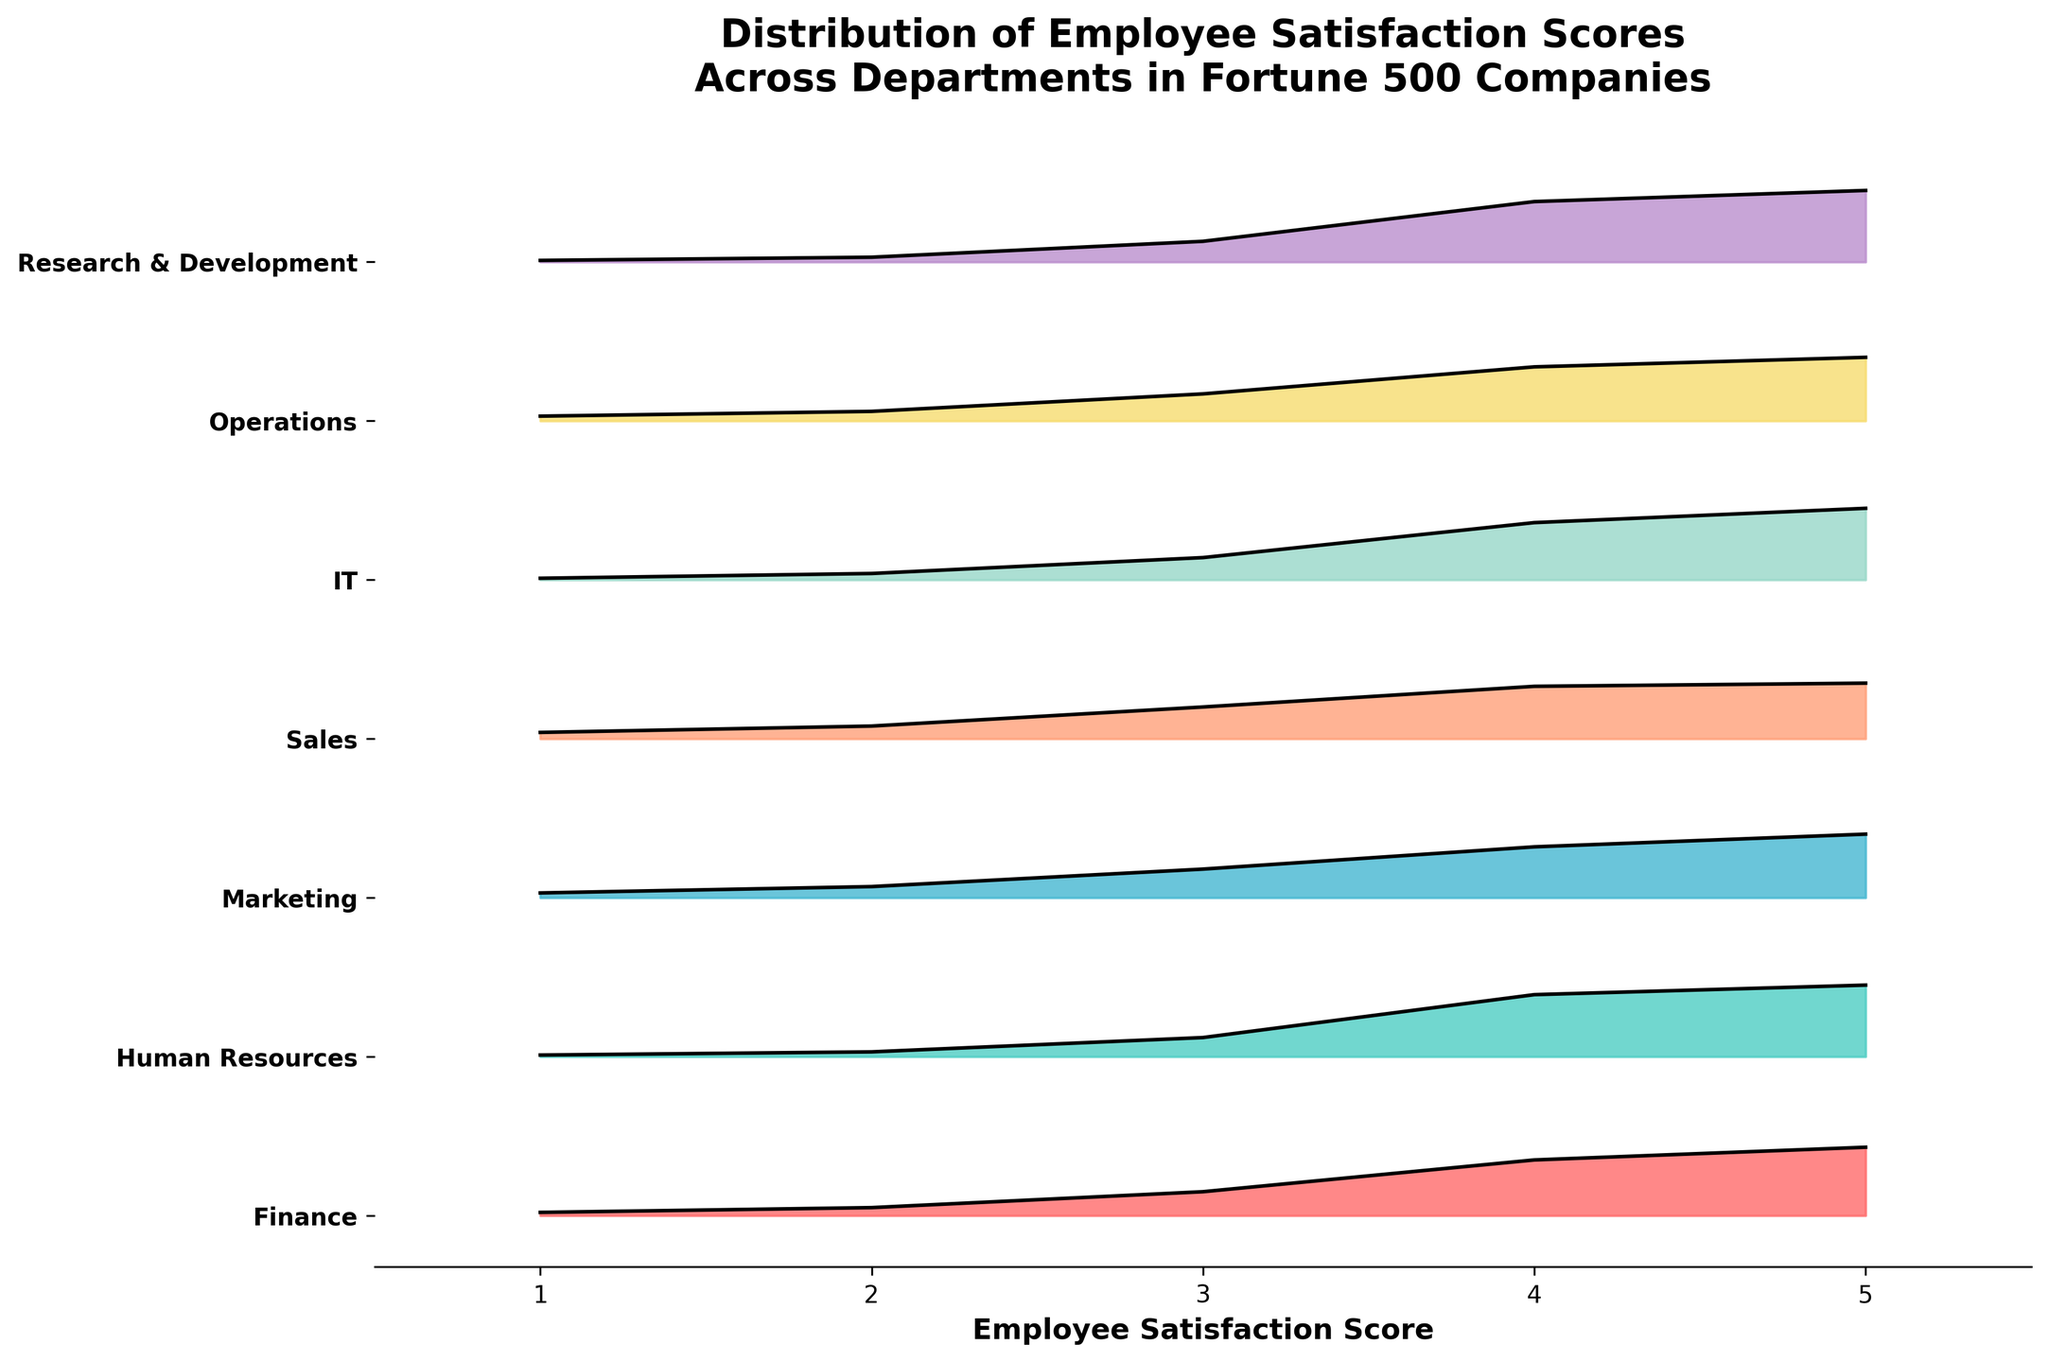What's the title of the plot? The title is displayed at the top of the plot, it provides information on the subject being visualized.
Answer: Distribution of Employee Satisfaction Scores Across Departments in Fortune 500 Companies What are the departments shown in the plot? The departments can be identified from the labels on the y-axis of the plot. They include Finance, Human Resources, Marketing, Sales, IT, Operations, and Research & Development.
Answer: Finance, Human Resources, Marketing, Sales, IT, Operations, Research & Development Which department has the highest density for employee satisfaction score 5? By comparing the density values for satisfaction score 5 across all departments in the plot, we see that Human Resources, IT, and Research & Development all have the highest density value of 0.45.
Answer: Human Resources, IT, Research & Development What's the general trend in employee satisfaction scores across departments? The general trend can be observed by noting the shape of the density curves across the departments. The density values often increase towards higher satisfaction scores, indicating higher satisfaction generally.
Answer: Higher satisfaction generally Which department shows the widest distribution of satisfaction scores? The widest distribution could be inferred by comparing the spread of the density curves for each department. Sales appears to have the widest distribution as it has noticeable density values across the entire score range.
Answer: Sales Compare the satisfaction score distribution between Finance and Marketing. Analyze the density curves for Finance and Marketing. Finance has higher densities at scores 4 and 5, whereas Marketing has slightly lower densities at these scores but a relatively high density at 3.
Answer: Finance has higher satisfaction scores at 4 and 5, Marketing has relatively high density at 3 Do any departments exhibit low satisfaction scores (1 and 2)? Checking the densities for scores 1 and 2 across all departments, we see that Sales and Marketing exhibit non-zero densities at these low scores more prominently than other departments.
Answer: Sales, Marketing Which department's satisfaction scores are most clustered around score 4? By looking at the density values for score 4, Human Resources, IT, and Research & Development have high densities for this score.
Answer: Human Resources, IT, Research & Development What's the difference in density for score 5 between Sales and IT? The density for score 5 in Sales is 0.35, while in IT it is 0.45. The difference is calculated as 0.45 - 0.35.
Answer: 0.10 What does the x-axis represent in the plot? The x-axis represents the employee satisfaction scores, ranging from 1 to 5, indicating different levels of satisfaction.
Answer: Employee Satisfaction Score 